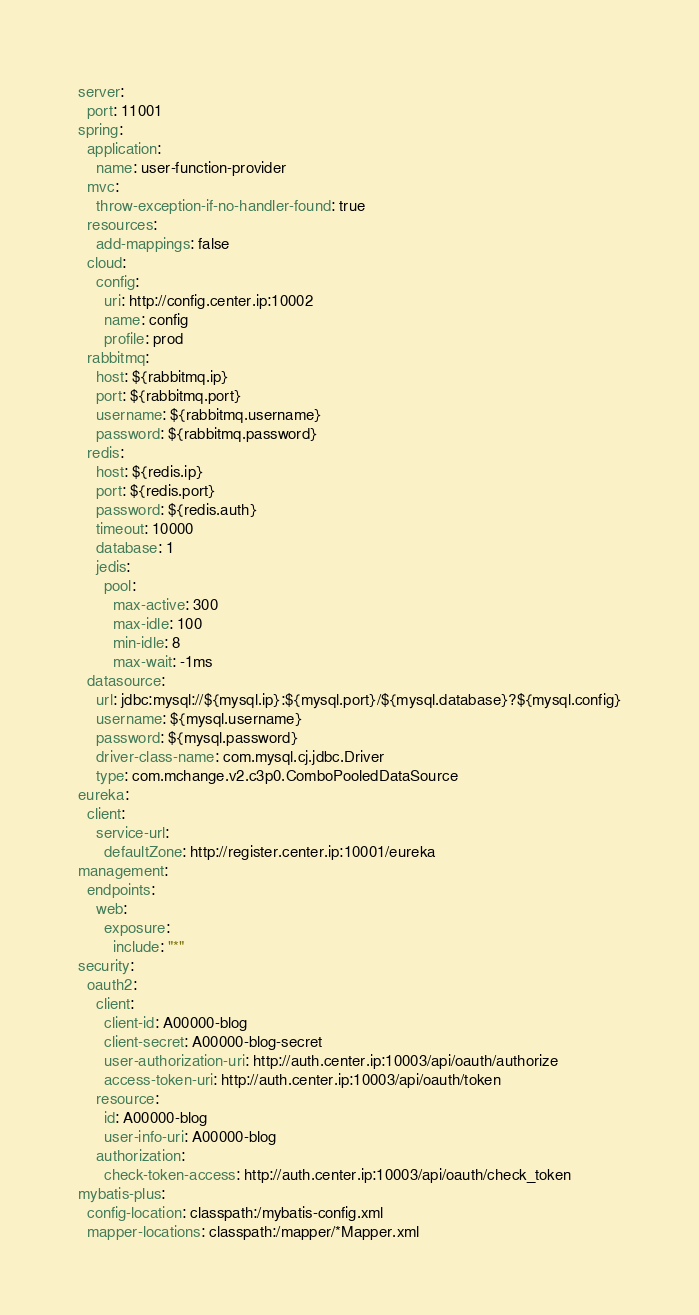<code> <loc_0><loc_0><loc_500><loc_500><_YAML_>server:
  port: 11001
spring:
  application:
    name: user-function-provider
  mvc:
    throw-exception-if-no-handler-found: true
  resources:
    add-mappings: false
  cloud:
    config:
      uri: http://config.center.ip:10002
      name: config
      profile: prod
  rabbitmq:
    host: ${rabbitmq.ip}
    port: ${rabbitmq.port}
    username: ${rabbitmq.username}
    password: ${rabbitmq.password}
  redis:
    host: ${redis.ip}
    port: ${redis.port}
    password: ${redis.auth}
    timeout: 10000
    database: 1
    jedis:
      pool:
        max-active: 300
        max-idle: 100
        min-idle: 8
        max-wait: -1ms
  datasource:
    url: jdbc:mysql://${mysql.ip}:${mysql.port}/${mysql.database}?${mysql.config}
    username: ${mysql.username}
    password: ${mysql.password}
    driver-class-name: com.mysql.cj.jdbc.Driver
    type: com.mchange.v2.c3p0.ComboPooledDataSource
eureka:
  client:
    service-url:
      defaultZone: http://register.center.ip:10001/eureka
management:
  endpoints:
    web:
      exposure:
        include: "*"
security:
  oauth2:
    client:
      client-id: A00000-blog
      client-secret: A00000-blog-secret
      user-authorization-uri: http://auth.center.ip:10003/api/oauth/authorize
      access-token-uri: http://auth.center.ip:10003/api/oauth/token
    resource:
      id: A00000-blog
      user-info-uri: A00000-blog
    authorization:
      check-token-access: http://auth.center.ip:10003/api/oauth/check_token
mybatis-plus:
  config-location: classpath:/mybatis-config.xml
  mapper-locations: classpath:/mapper/*Mapper.xml</code> 